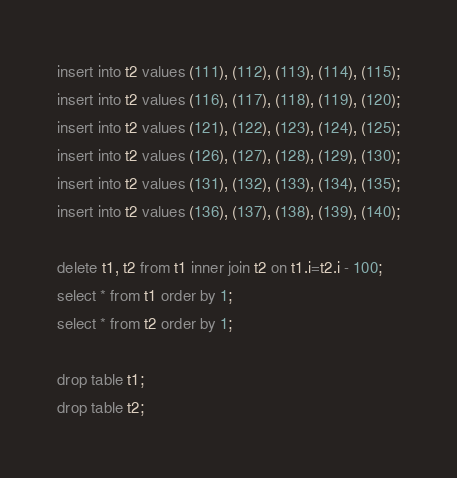Convert code to text. <code><loc_0><loc_0><loc_500><loc_500><_SQL_>insert into t2 values (111), (112), (113), (114), (115);
insert into t2 values (116), (117), (118), (119), (120);
insert into t2 values (121), (122), (123), (124), (125);
insert into t2 values (126), (127), (128), (129), (130);
insert into t2 values (131), (132), (133), (134), (135);
insert into t2 values (136), (137), (138), (139), (140);

delete t1, t2 from t1 inner join t2 on t1.i=t2.i - 100;
select * from t1 order by 1;
select * from t2 order by 1;

drop table t1;
drop table t2;</code> 